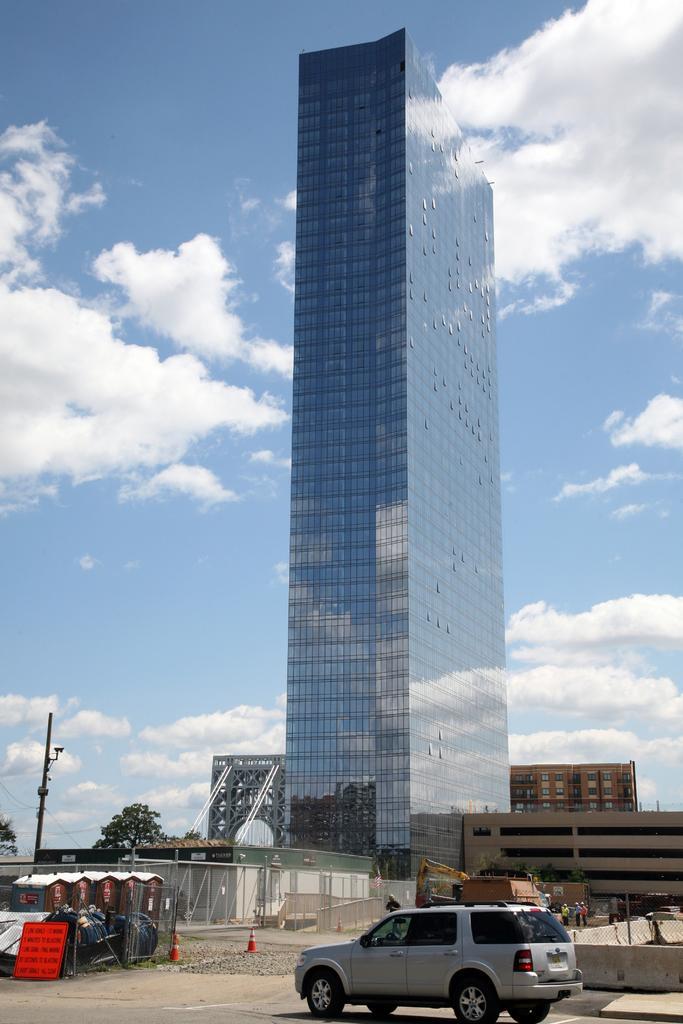In one or two sentences, can you explain what this image depicts? In the center of the image there is a building. At the bottom there are buildings, pole, cat, road and traffic cone. In the background there is sky and clouds. 